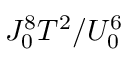<formula> <loc_0><loc_0><loc_500><loc_500>J _ { 0 } ^ { 8 } T ^ { 2 } / U _ { 0 } ^ { 6 }</formula> 